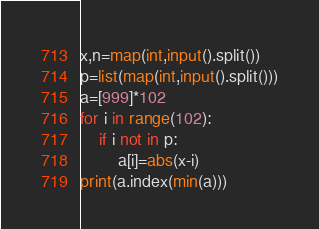Convert code to text. <code><loc_0><loc_0><loc_500><loc_500><_Python_>x,n=map(int,input().split())
p=list(map(int,input().split()))
a=[999]*102
for i in range(102):
    if i not in p:
        a[i]=abs(x-i)
print(a.index(min(a)))</code> 